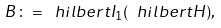Convert formula to latex. <formula><loc_0><loc_0><loc_500><loc_500>\ B \colon = \ h i l b e r t { I } _ { 1 } ( \ h i l b e r t { H } ) ,</formula> 